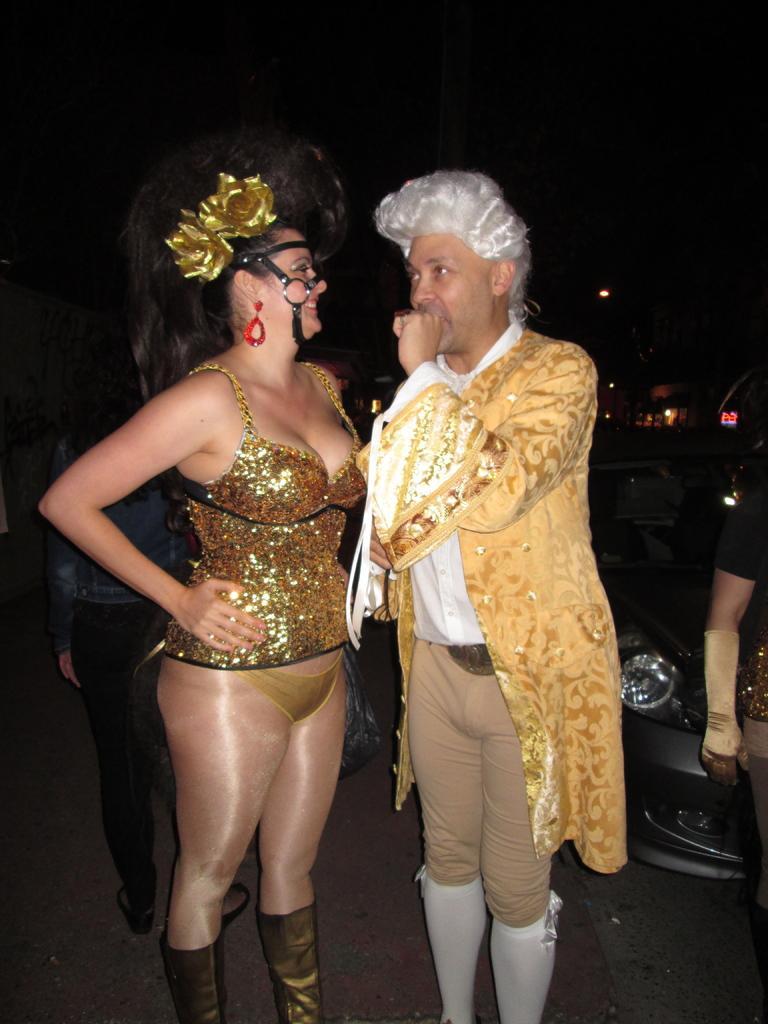Please provide a concise description of this image. In this image there is a man and woman standing. They are wearing costumes. To the right of the image there is car. Behind them there is another person. The background is dark. 